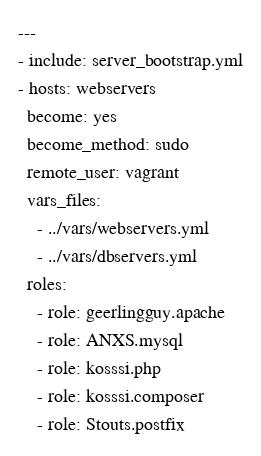Convert code to text. <code><loc_0><loc_0><loc_500><loc_500><_YAML_>---
- include: server_bootstrap.yml
- hosts: webservers
  become: yes
  become_method: sudo
  remote_user: vagrant
  vars_files:
    - ../vars/webservers.yml
    - ../vars/dbservers.yml
  roles:
    - role: geerlingguy.apache
    - role: ANXS.mysql
    - role: kosssi.php
    - role: kosssi.composer
    - role: Stouts.postfix
</code> 